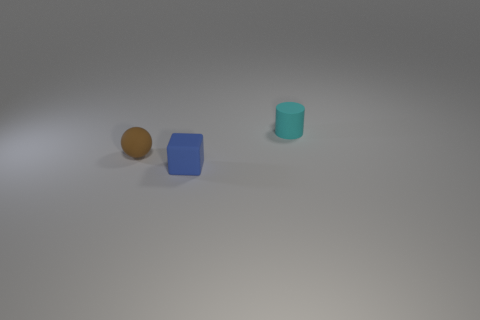The tiny object that is in front of the rubber object on the left side of the matte block is made of what material?
Offer a very short reply. Rubber. There is a matte cylinder to the right of the matte cube; how big is it?
Make the answer very short. Small. There is a object that is behind the small blue cube and right of the brown rubber thing; what is its color?
Ensure brevity in your answer.  Cyan. Are there any small things in front of the tiny object that is left of the blue rubber cube?
Provide a succinct answer. Yes. Are there an equal number of tiny cyan rubber cylinders that are in front of the small rubber ball and rubber objects that are in front of the cyan cylinder?
Offer a very short reply. No. Are there more small matte cylinders that are behind the blue matte thing than tiny red metal cylinders?
Provide a succinct answer. Yes. Is the size of the matte thing in front of the tiny brown matte thing the same as the matte object that is behind the small brown ball?
Ensure brevity in your answer.  Yes. The cyan rubber cylinder has what size?
Offer a terse response. Small. What is the color of the cube that is made of the same material as the small brown sphere?
Provide a short and direct response. Blue. How many brown spheres have the same material as the cyan cylinder?
Offer a terse response. 1. 